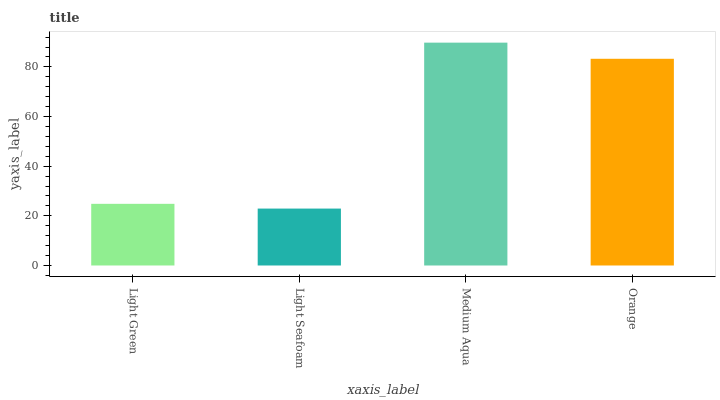Is Light Seafoam the minimum?
Answer yes or no. Yes. Is Medium Aqua the maximum?
Answer yes or no. Yes. Is Medium Aqua the minimum?
Answer yes or no. No. Is Light Seafoam the maximum?
Answer yes or no. No. Is Medium Aqua greater than Light Seafoam?
Answer yes or no. Yes. Is Light Seafoam less than Medium Aqua?
Answer yes or no. Yes. Is Light Seafoam greater than Medium Aqua?
Answer yes or no. No. Is Medium Aqua less than Light Seafoam?
Answer yes or no. No. Is Orange the high median?
Answer yes or no. Yes. Is Light Green the low median?
Answer yes or no. Yes. Is Light Green the high median?
Answer yes or no. No. Is Orange the low median?
Answer yes or no. No. 